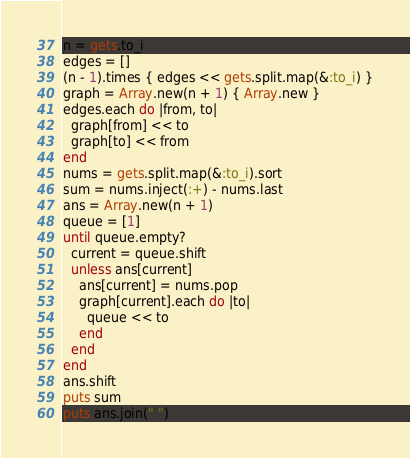<code> <loc_0><loc_0><loc_500><loc_500><_Ruby_>n = gets.to_i
edges = []
(n - 1).times { edges << gets.split.map(&:to_i) }
graph = Array.new(n + 1) { Array.new }
edges.each do |from, to|
  graph[from] << to
  graph[to] << from
end
nums = gets.split.map(&:to_i).sort
sum = nums.inject(:+) - nums.last
ans = Array.new(n + 1)
queue = [1]
until queue.empty?
  current = queue.shift
  unless ans[current]
    ans[current] = nums.pop
    graph[current].each do |to|
      queue << to
    end
  end
end
ans.shift
puts sum
puts ans.join(" ")
</code> 